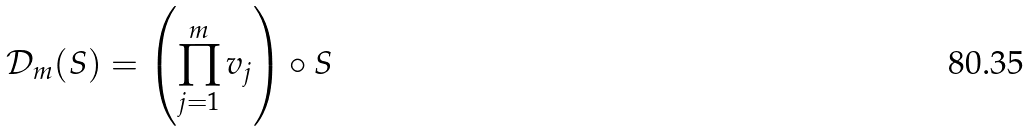<formula> <loc_0><loc_0><loc_500><loc_500>\mathcal { D } _ { m } ( S ) = \left ( \prod _ { j = 1 } ^ { m } v _ { j } \right ) \circ S</formula> 